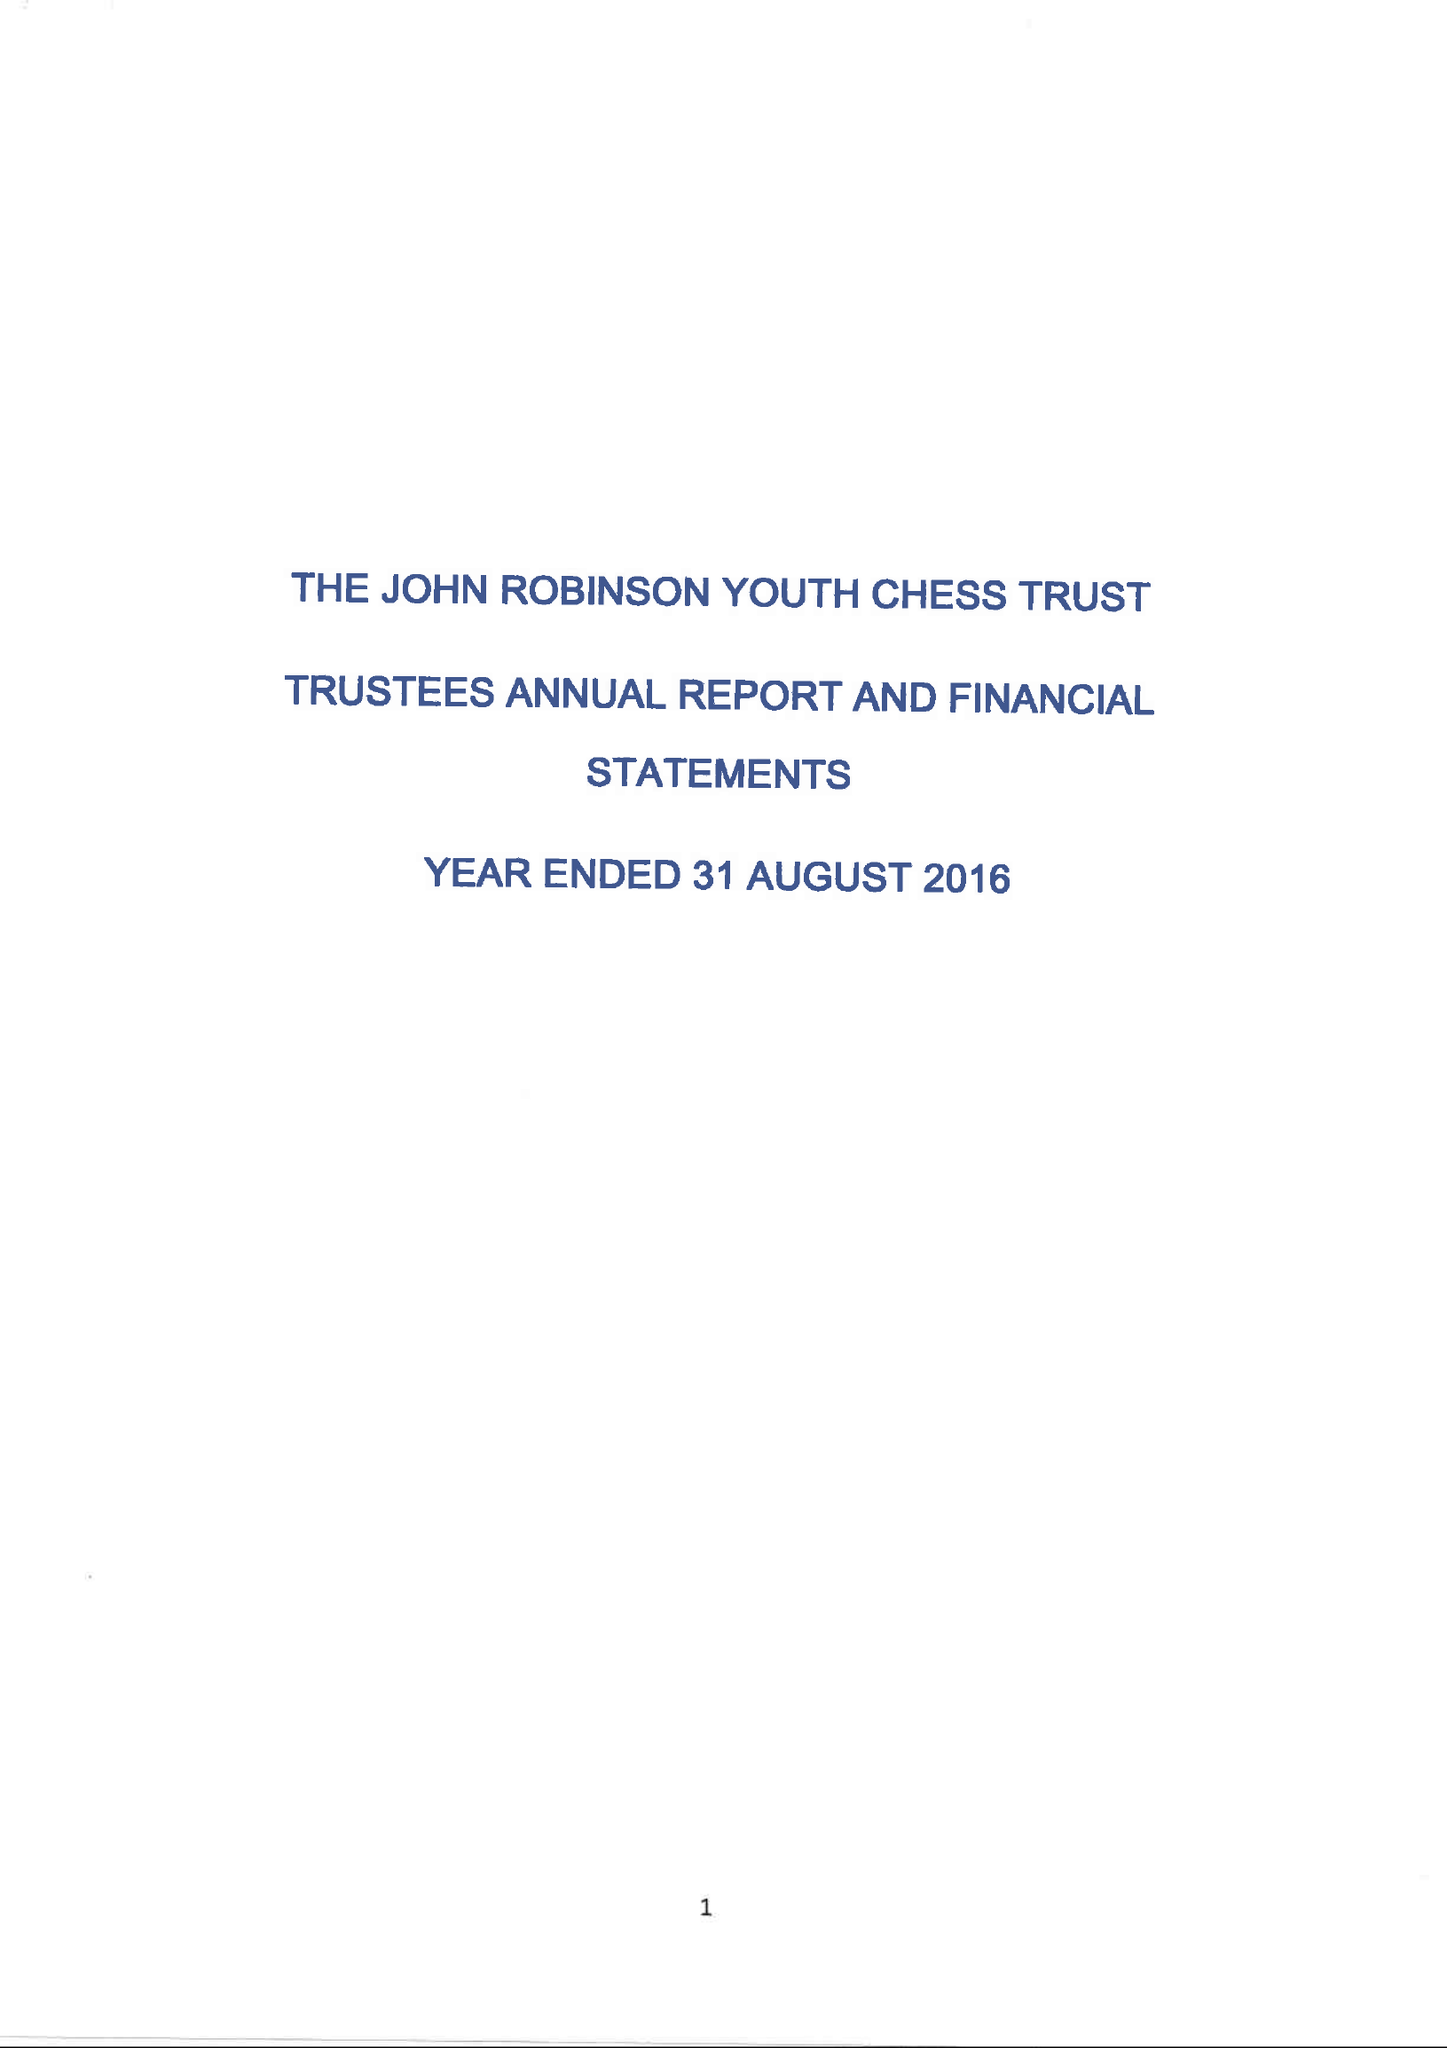What is the value for the income_annually_in_british_pounds?
Answer the question using a single word or phrase. 28397.00 